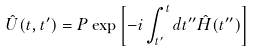<formula> <loc_0><loc_0><loc_500><loc_500>\hat { U } ( t , t ^ { \prime } ) = P \exp \left [ - i \int _ { t ^ { \prime } } ^ { t } d t ^ { \prime \prime } \hat { H } ( t ^ { \prime \prime } ) \right ] \</formula> 